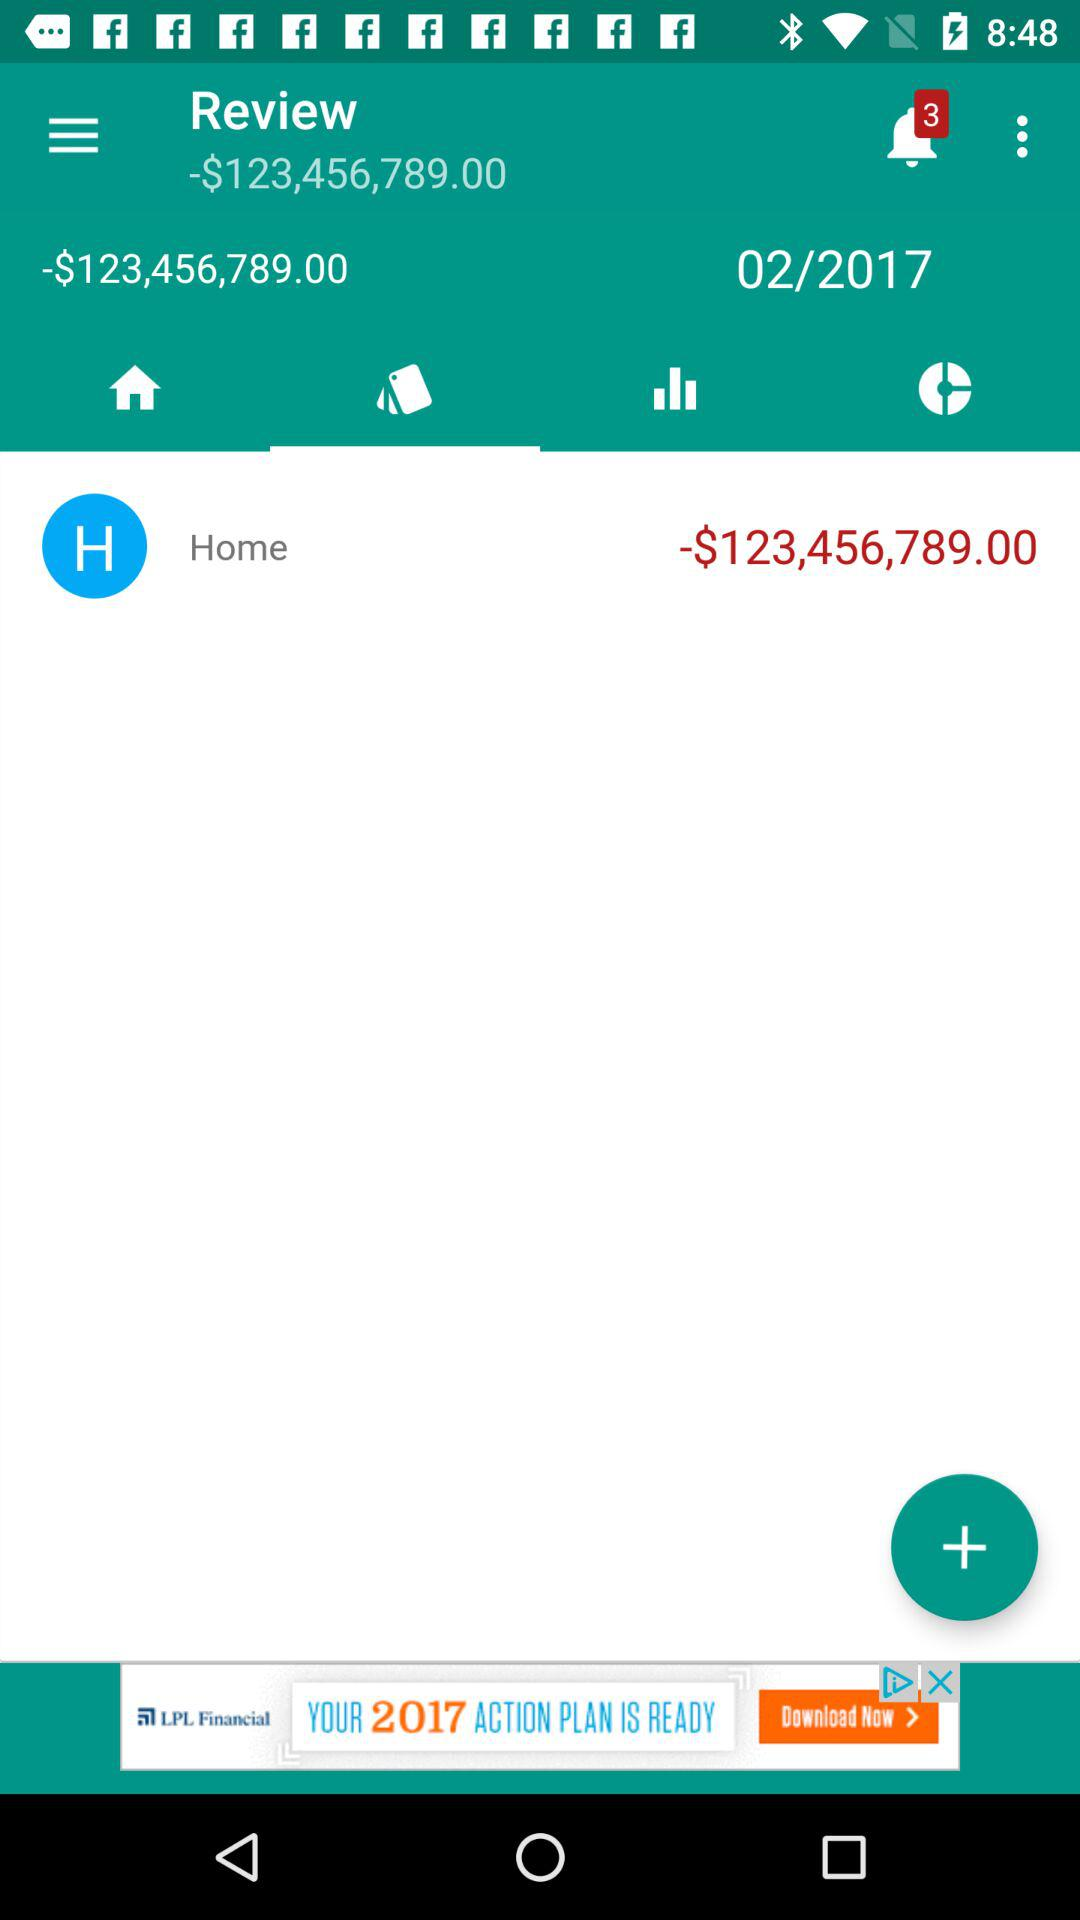What is the currency of the price? The currency of the price is $. 